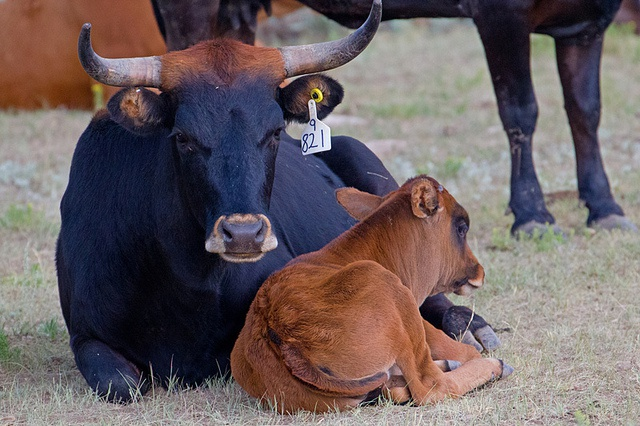Describe the objects in this image and their specific colors. I can see cow in gray, black, navy, purple, and darkblue tones, cow in gray, brown, and maroon tones, cow in gray, black, navy, and darkgray tones, and cow in gray, brown, and maroon tones in this image. 